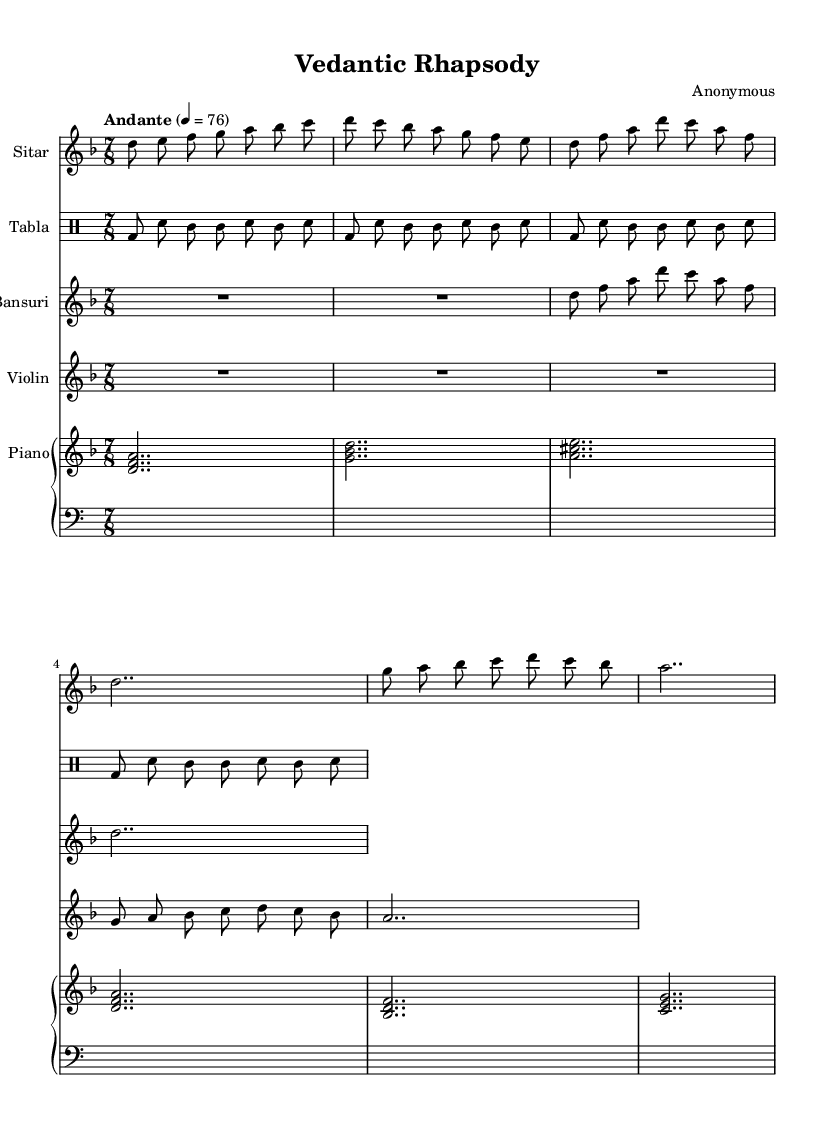What is the key signature of this music? The key signature indicated in the global section of the sheet music is D minor, which has one flat (the B flat).
Answer: D minor What is the time signature of this piece? The time signature shown in the global section is 7/8, meaning there are 7 eighth notes in each measure.
Answer: 7/8 What is the tempo marking for this composition? The tempo marking in the global section specifies "Andante," which translates to a moderate tempo, typically around 76 beats per minute.
Answer: Andante Which instruments are featured in this composition? By examining the score, you can see that the instruments included are Sitar, Tabla, Bansuri, Violin, and Piano.
Answer: Sitar, Tabla, Bansuri, Violin, Piano What rhythmic pattern does the Tabla follow? The tabla rhythm pattern consists of a cycle of bass drum (bd) and snare (sn) followed by a repeated tom (tomml) sound, laid out in 8th notes.
Answer: bd sn tomml How does the Bansuri's melody relate to the overall structure? The Bansuri plays a melody that begins with a rest, and then follows with a sequence that emphasizes a specific note pattern leading back to the tonic, contributing to the overall harmonic structure of the piece.
Answer: It emphasizes a specific note pattern What fusion elements can be identified in this piece? The piece exemplifies a fusion of Indian classical styles, represented by the sitar, bansuri, and tabla, with Western elements expressed in the harmonic and instrumental textures like the piano and violin.
Answer: Indian classical and Western elements 